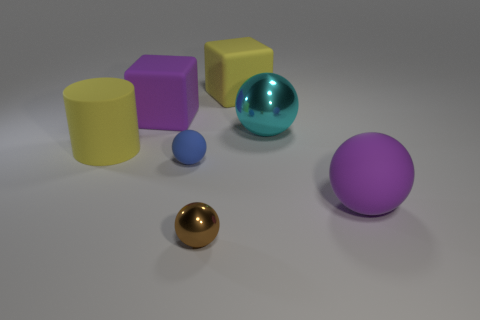There is a cyan metallic thing; is its size the same as the yellow thing right of the small brown thing?
Provide a short and direct response. Yes. What is the material of the large ball behind the purple sphere?
Make the answer very short. Metal. What number of objects are in front of the yellow matte thing that is to the left of the tiny matte thing?
Provide a short and direct response. 3. Are there any big cyan metallic objects of the same shape as the brown object?
Make the answer very short. Yes. Is the size of the purple thing to the left of the big metallic object the same as the rubber ball to the left of the large cyan object?
Your answer should be compact. No. The big yellow matte thing that is to the right of the matte cube on the left side of the blue object is what shape?
Offer a very short reply. Cube. How many things are the same size as the purple block?
Keep it short and to the point. 4. Are any big rubber cylinders visible?
Provide a succinct answer. Yes. Is there any other thing that is the same color as the cylinder?
Provide a short and direct response. Yes. What shape is the purple thing that is the same material as the large purple block?
Keep it short and to the point. Sphere. 